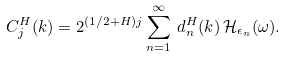<formula> <loc_0><loc_0><loc_500><loc_500>C ^ { H } _ { j } ( k ) = 2 ^ { ( 1 / 2 + H ) j } \sum ^ { \infty } _ { n = 1 } \, d ^ { H } _ { n } ( k ) \, \mathcal { H } _ { \epsilon _ { n } } ( \omega ) .</formula> 